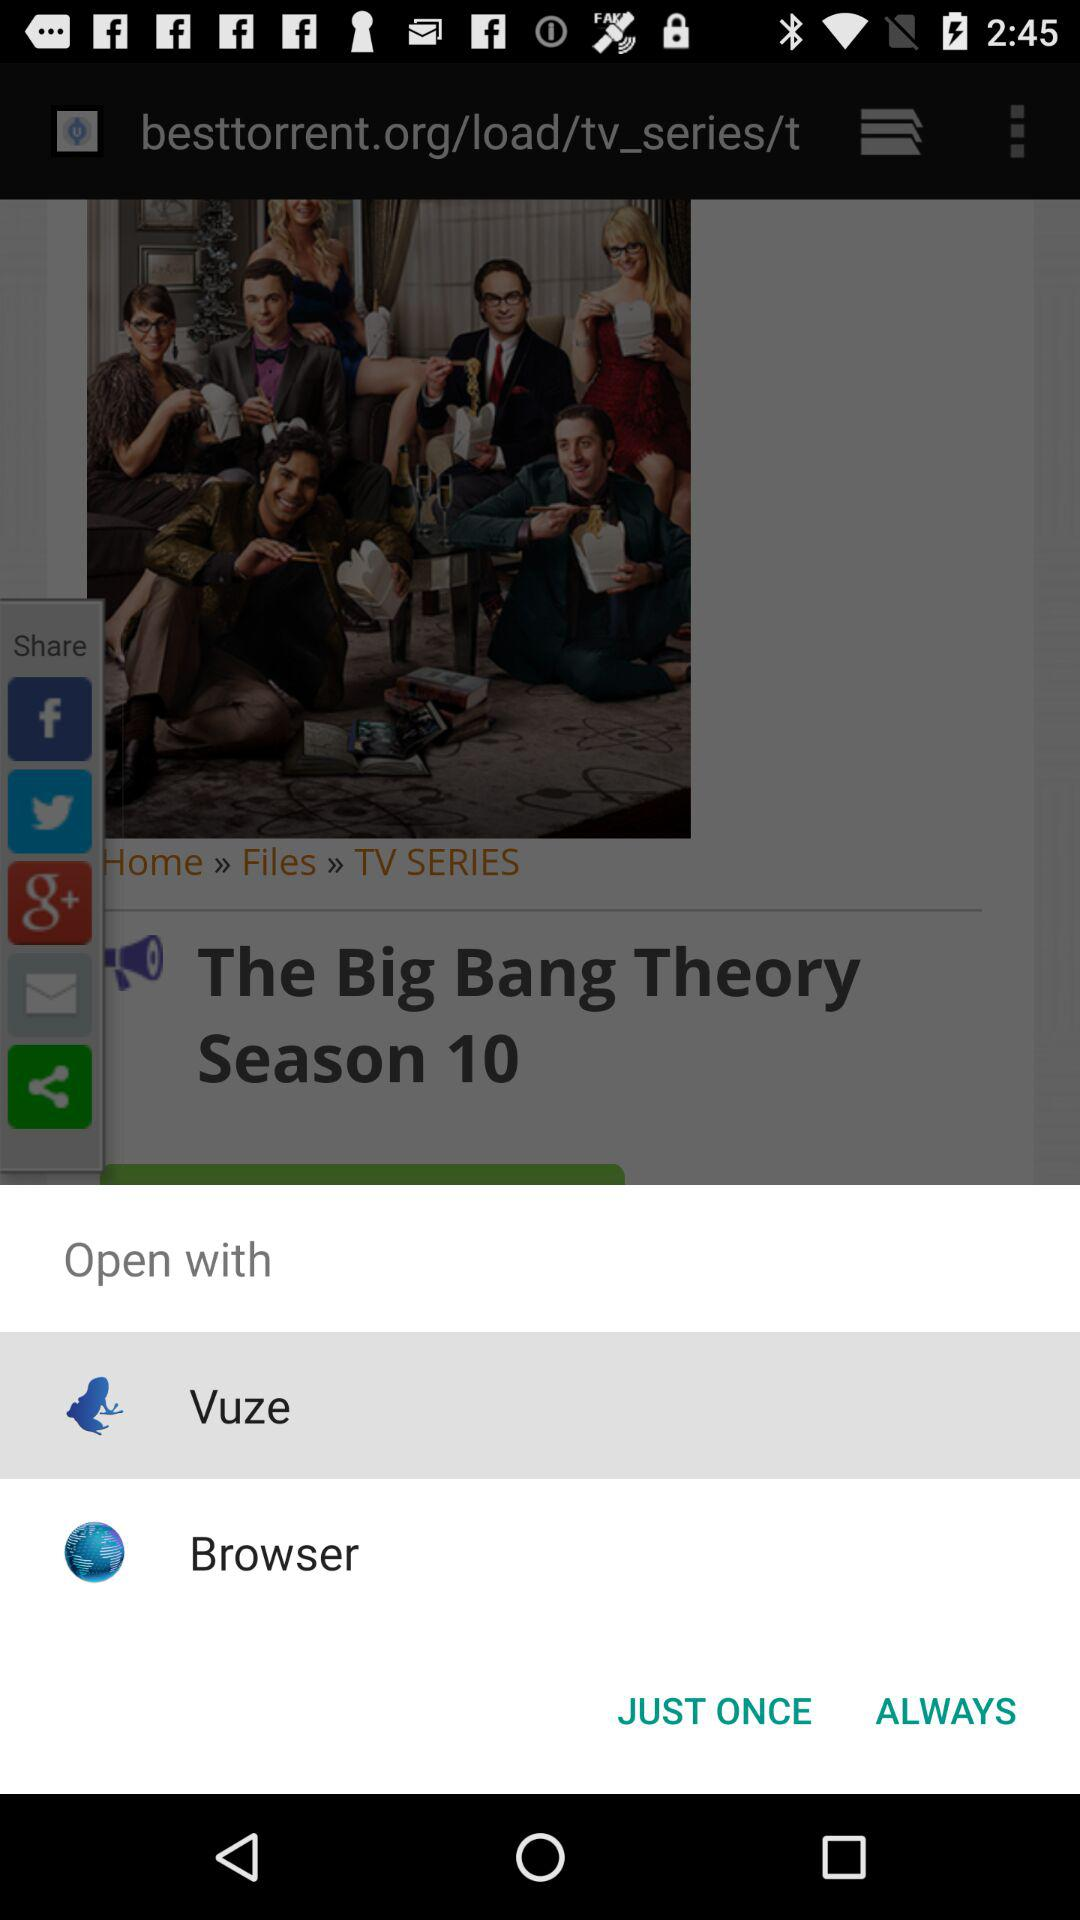What is the title of the TV series? The title is "The Big Bang Theory". 